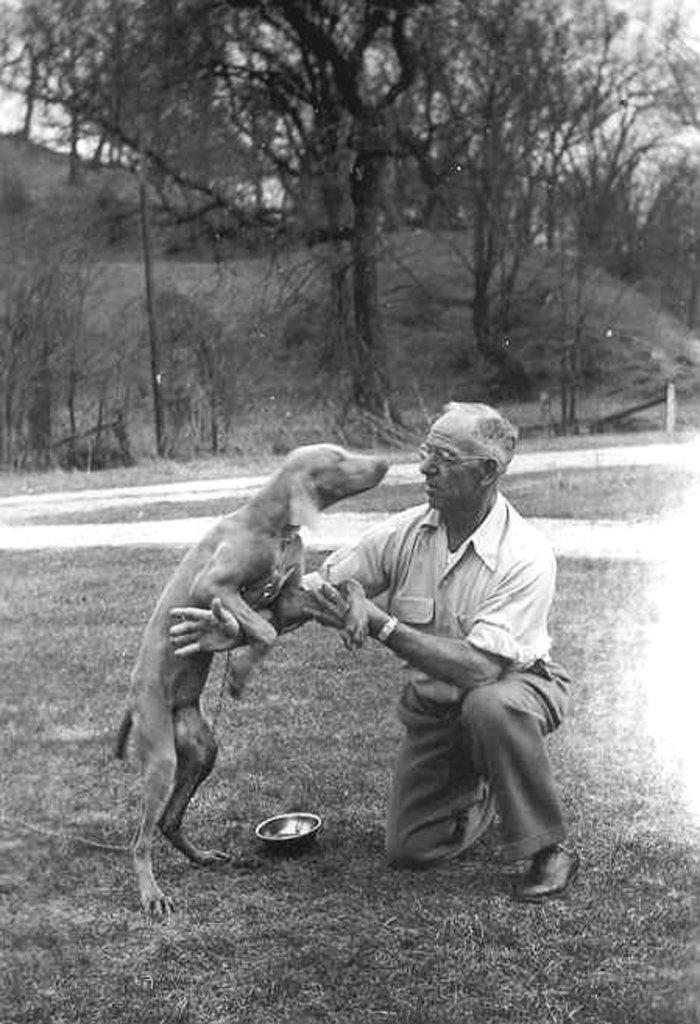Who is present in the image? There is a man in the image. What is the man holding? The man is holding a dog. What type of surface is visible at the bottom of the image? There is grass at the bottom of the image. What can be seen in the background of the image? There are trees at the top of the image. Where are the scissors located in the image? There are no scissors present in the image. What type of potato can be seen growing in the grass? There is no potato visible in the image; only grass and trees are present. 